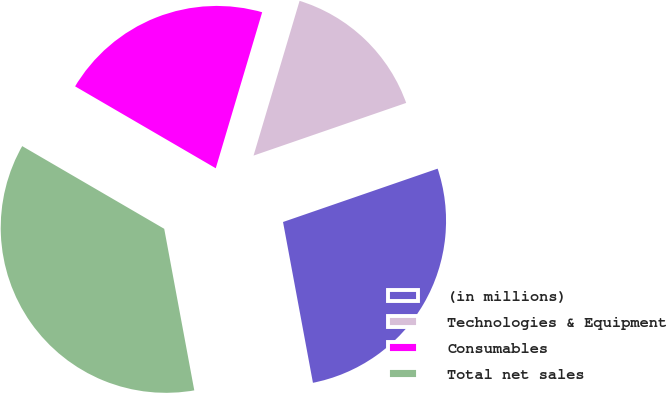Convert chart. <chart><loc_0><loc_0><loc_500><loc_500><pie_chart><fcel>(in millions)<fcel>Technologies & Equipment<fcel>Consumables<fcel>Total net sales<nl><fcel>27.36%<fcel>15.11%<fcel>21.21%<fcel>36.32%<nl></chart> 